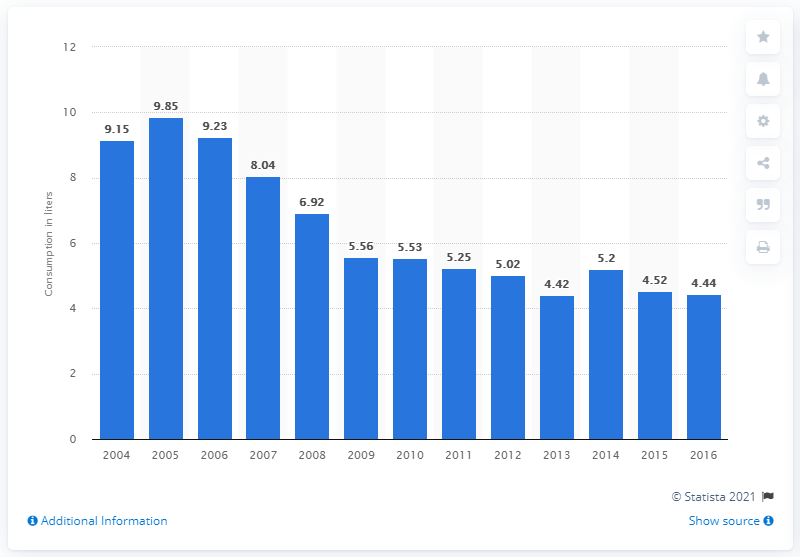Outline some significant characteristics in this image. In 2004, Canada's ice cream consumption per capita was 4.52. In Canada in 2016, the average person consumed 4.44 liters of ice cream, indicating a high demand for this sweet treat. 